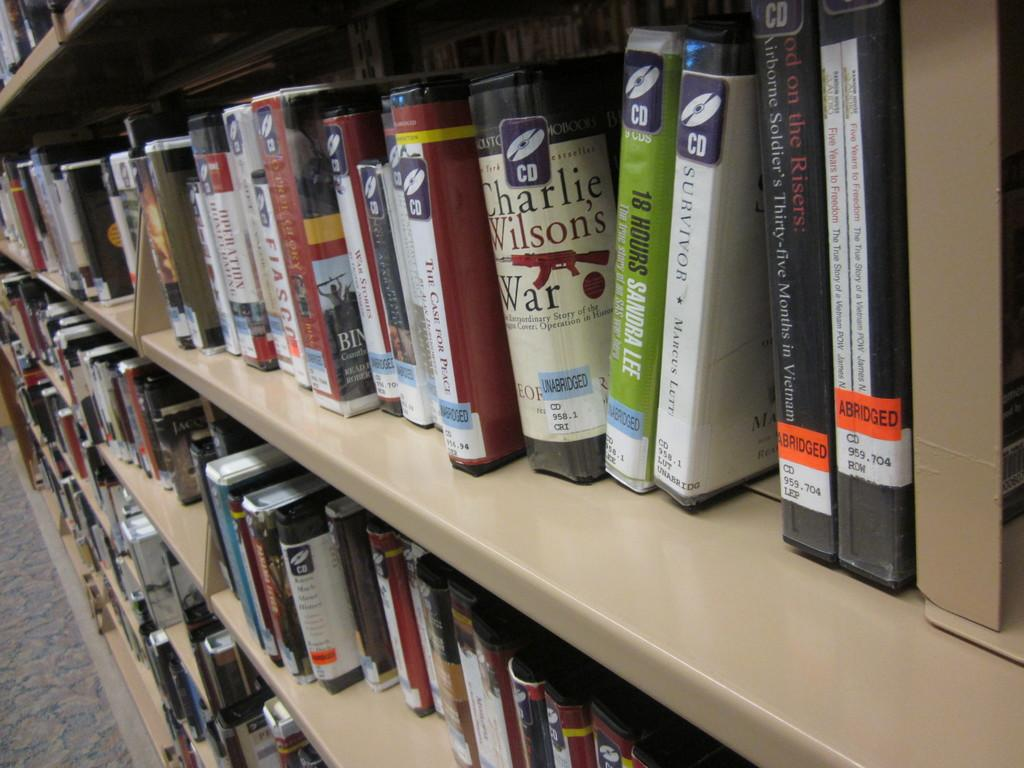<image>
Create a compact narrative representing the image presented. Rows of audio books on a library shelf include titles such as Charlie Wilson's War, 18 Hours and The Case for Peace. 